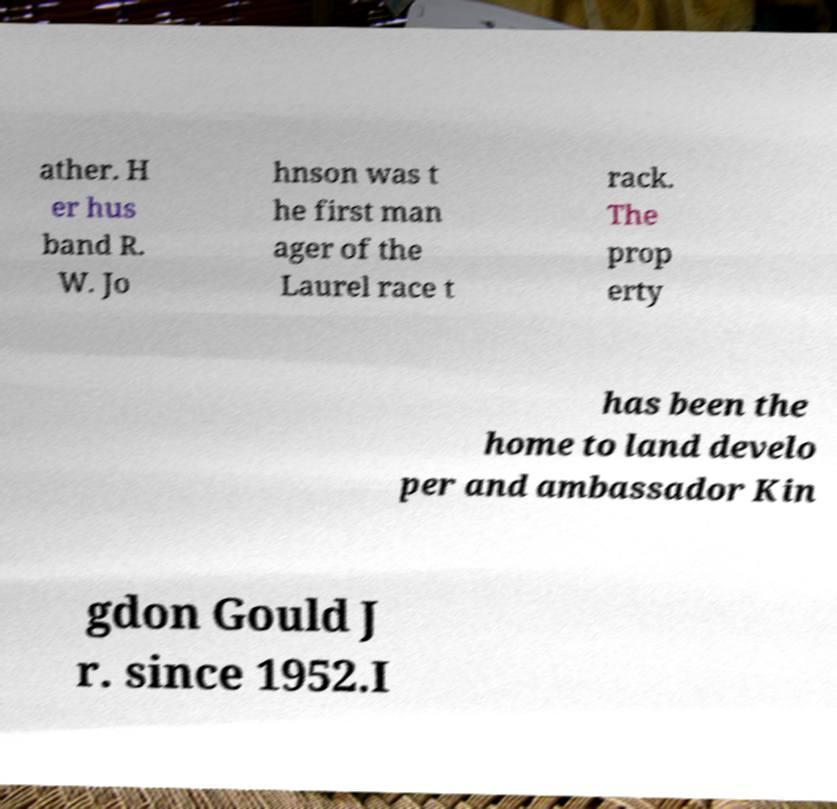Can you accurately transcribe the text from the provided image for me? ather. H er hus band R. W. Jo hnson was t he first man ager of the Laurel race t rack. The prop erty has been the home to land develo per and ambassador Kin gdon Gould J r. since 1952.I 